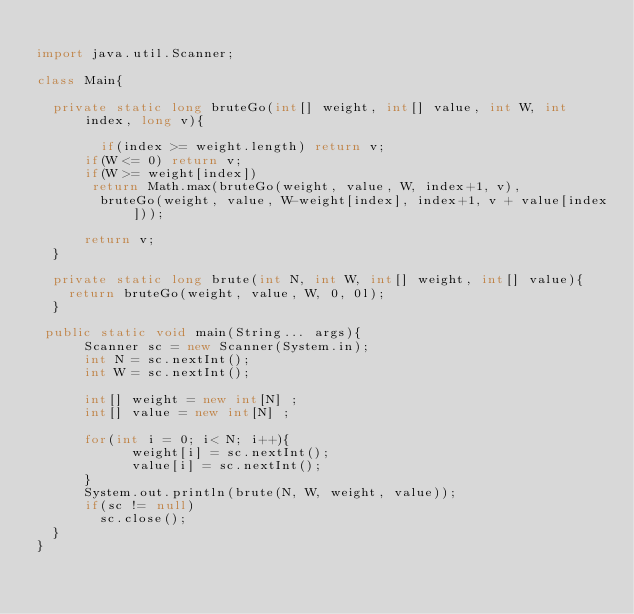<code> <loc_0><loc_0><loc_500><loc_500><_Java_>
import java.util.Scanner;

class Main{
  
  private static long bruteGo(int[] weight, int[] value, int W, int index, long v){
    
  		if(index >= weight.length) return v;
      if(W <= 0) return v;
      if(W >= weight[index])
       return Math.max(bruteGo(weight, value, W, index+1, v),
        bruteGo(weight, value, W-weight[index], index+1, v + value[index]));
      
      return v;
  }
  
  private static long brute(int N, int W, int[] weight, int[] value){
    return bruteGo(weight, value, W, 0, 0l);
  }
    
 public static void main(String... args){
      Scanner sc = new Scanner(System.in);
      int N = sc.nextInt();
      int W = sc.nextInt();

      int[] weight = new int[N] ;
      int[] value = new int[N] ;

      for(int i = 0; i< N; i++){
            weight[i] = sc.nextInt();
            value[i] = sc.nextInt();
      }
      System.out.println(brute(N, W, weight, value));
      if(sc != null)
        sc.close();
  }
}
</code> 